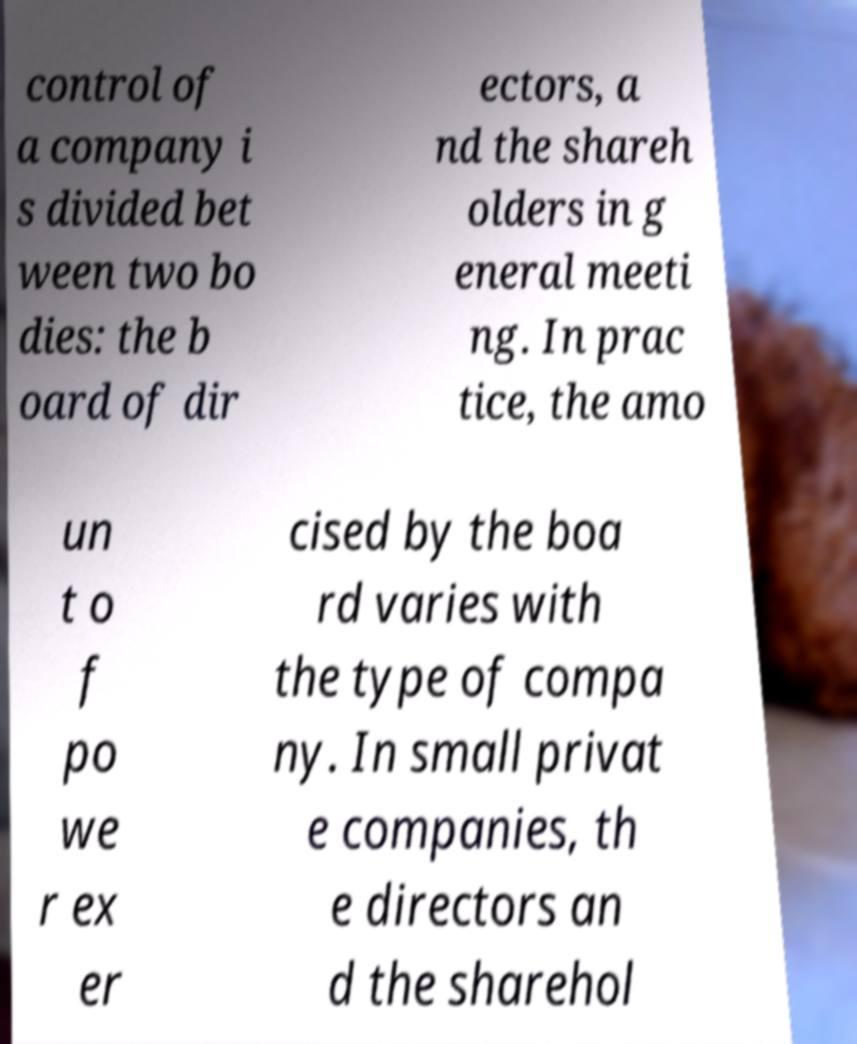What messages or text are displayed in this image? I need them in a readable, typed format. control of a company i s divided bet ween two bo dies: the b oard of dir ectors, a nd the shareh olders in g eneral meeti ng. In prac tice, the amo un t o f po we r ex er cised by the boa rd varies with the type of compa ny. In small privat e companies, th e directors an d the sharehol 